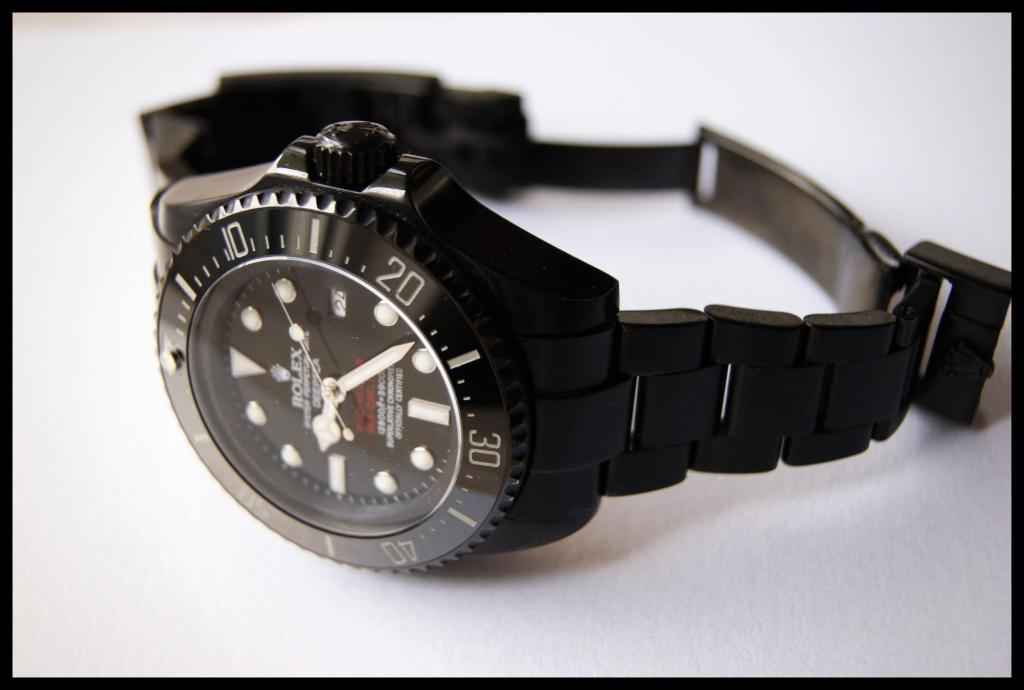Provide a one-sentence caption for the provided image. Rolex watch that says the time, which is 9:22. 